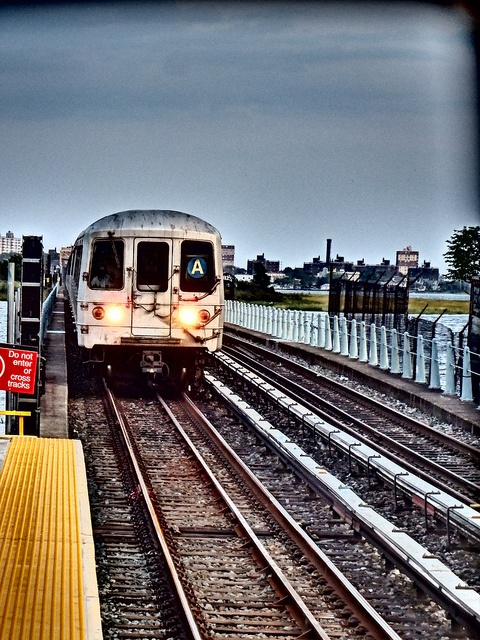Describe the objects in this image and their specific colors. I can see train in black, lightgray, tan, and darkgray tones and people in black and gray tones in this image. 